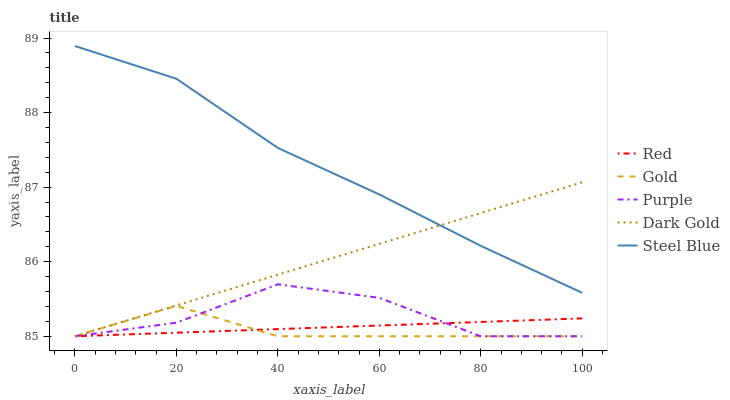Does Gold have the minimum area under the curve?
Answer yes or no. Yes. Does Steel Blue have the maximum area under the curve?
Answer yes or no. Yes. Does Steel Blue have the minimum area under the curve?
Answer yes or no. No. Does Gold have the maximum area under the curve?
Answer yes or no. No. Is Red the smoothest?
Answer yes or no. Yes. Is Purple the roughest?
Answer yes or no. Yes. Is Steel Blue the smoothest?
Answer yes or no. No. Is Steel Blue the roughest?
Answer yes or no. No. Does Purple have the lowest value?
Answer yes or no. Yes. Does Steel Blue have the lowest value?
Answer yes or no. No. Does Steel Blue have the highest value?
Answer yes or no. Yes. Does Gold have the highest value?
Answer yes or no. No. Is Purple less than Steel Blue?
Answer yes or no. Yes. Is Steel Blue greater than Gold?
Answer yes or no. Yes. Does Red intersect Purple?
Answer yes or no. Yes. Is Red less than Purple?
Answer yes or no. No. Is Red greater than Purple?
Answer yes or no. No. Does Purple intersect Steel Blue?
Answer yes or no. No. 